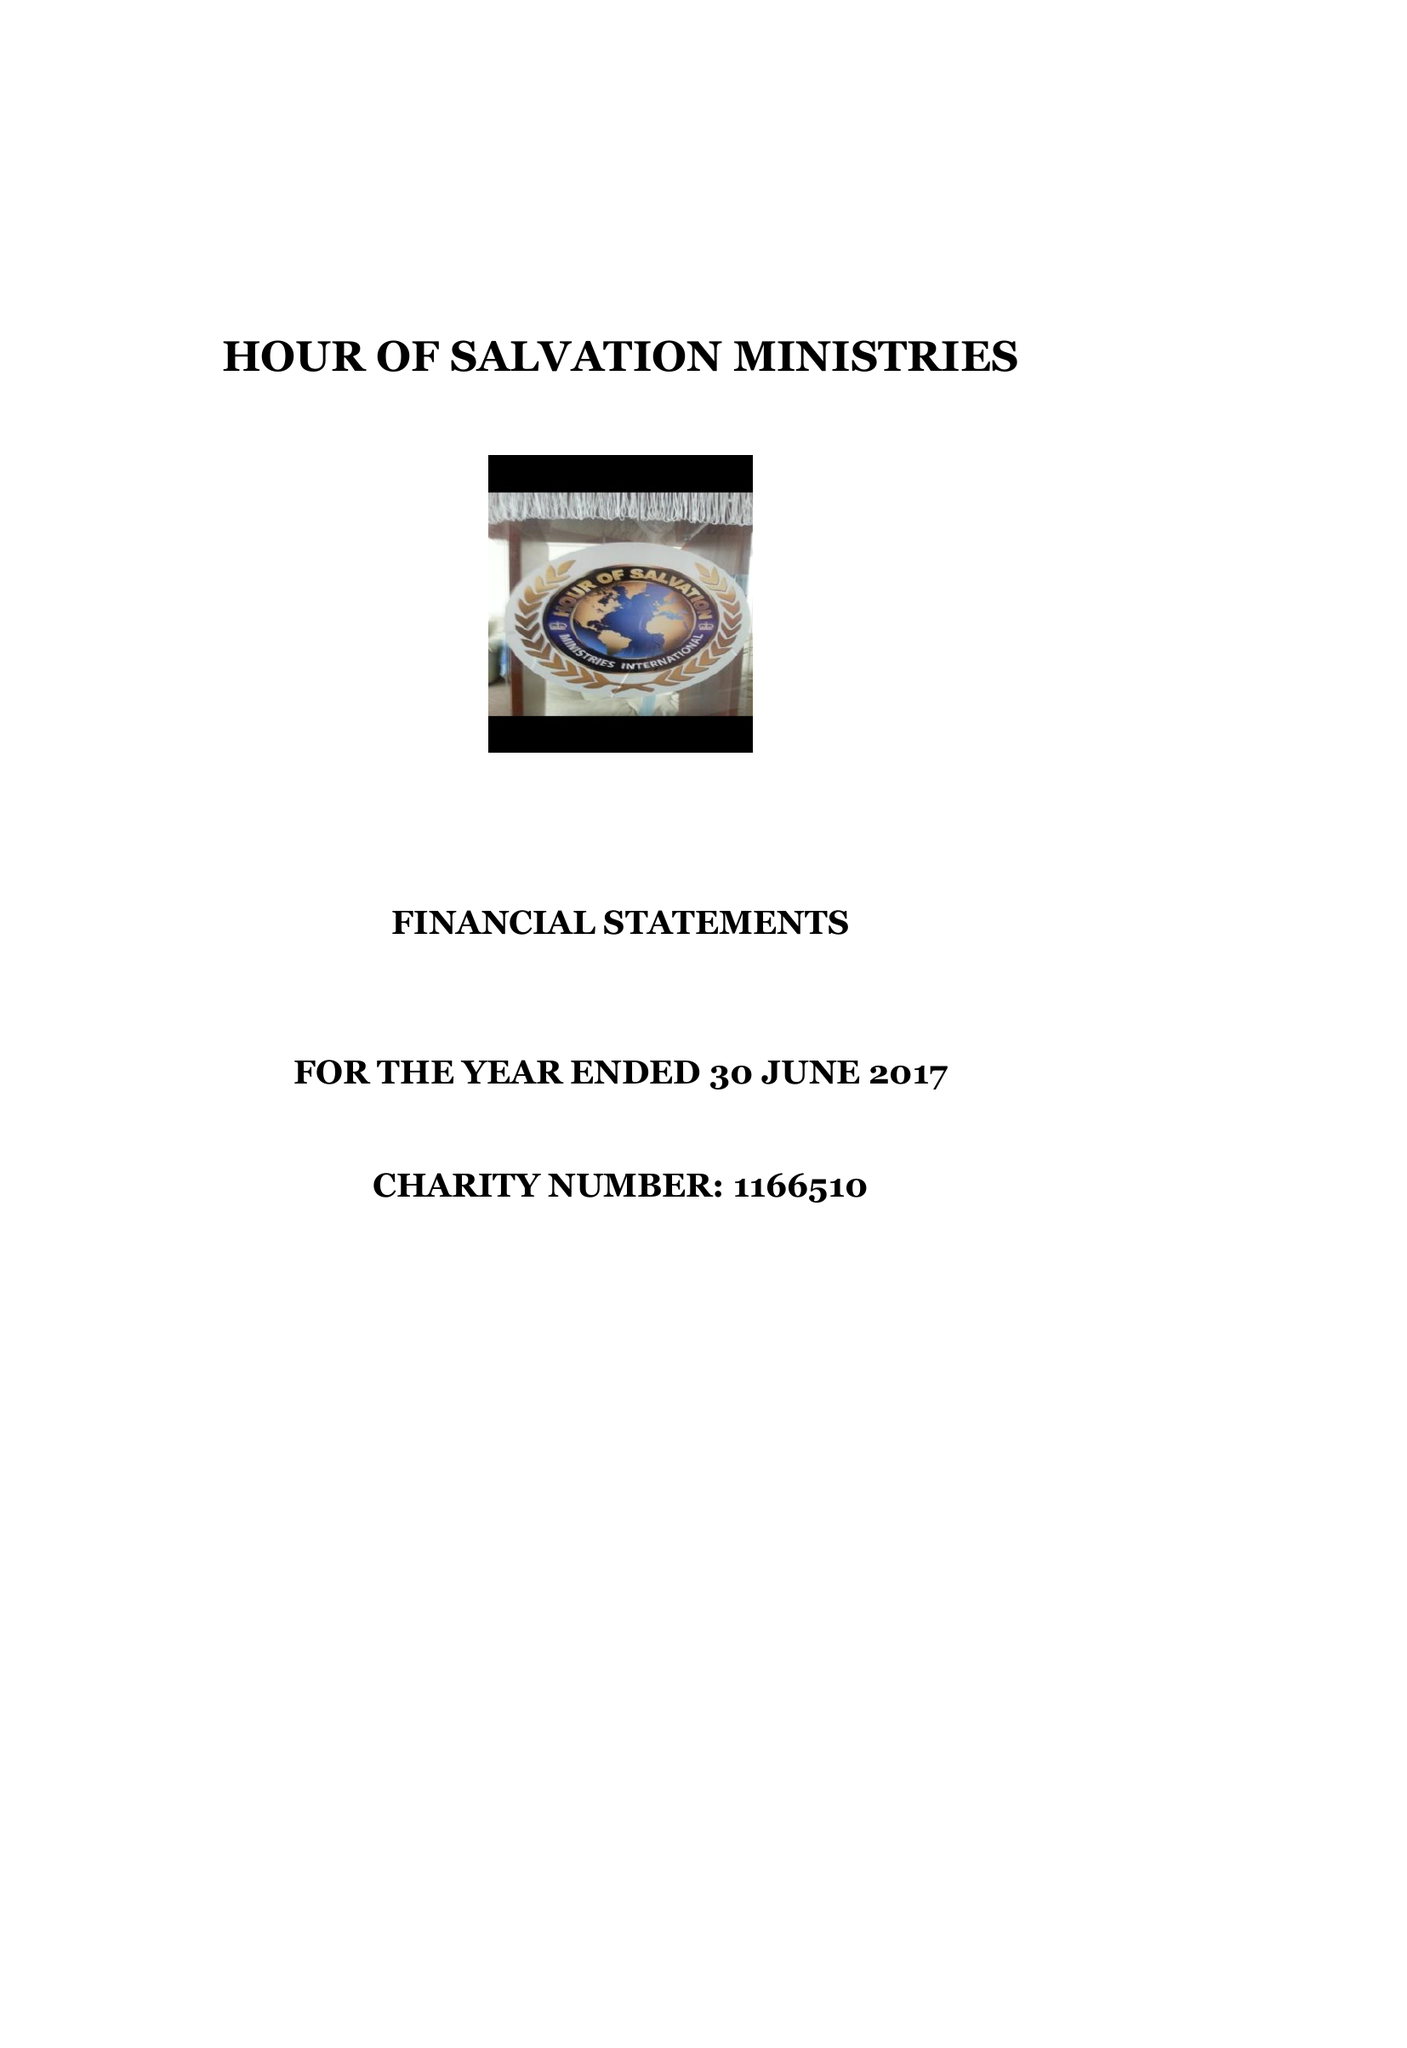What is the value for the spending_annually_in_british_pounds?
Answer the question using a single word or phrase. 10927.00 